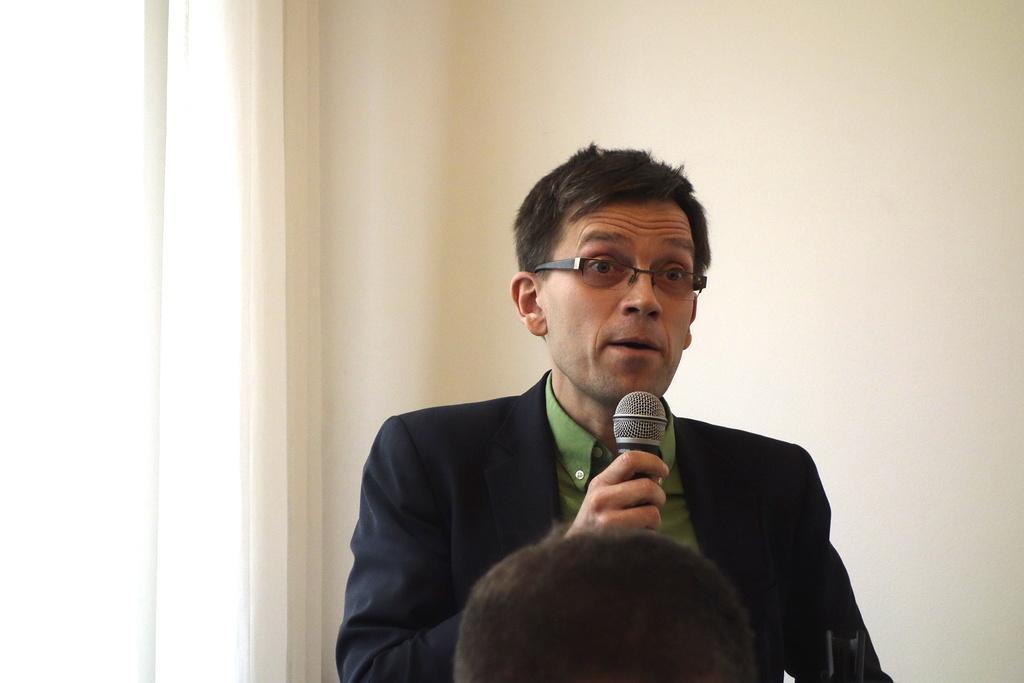Could you give a brief overview of what you see in this image? In this image there is a person wearing black color suit holding a microphone in his hand. 